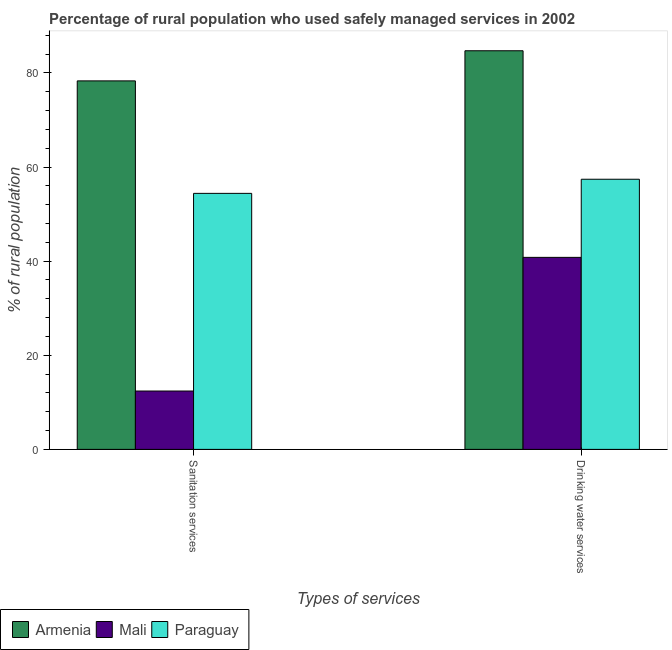How many different coloured bars are there?
Provide a succinct answer. 3. How many groups of bars are there?
Make the answer very short. 2. Are the number of bars on each tick of the X-axis equal?
Offer a terse response. Yes. What is the label of the 1st group of bars from the left?
Provide a short and direct response. Sanitation services. What is the percentage of rural population who used drinking water services in Paraguay?
Offer a very short reply. 57.4. Across all countries, what is the maximum percentage of rural population who used drinking water services?
Offer a terse response. 84.7. In which country was the percentage of rural population who used drinking water services maximum?
Your answer should be compact. Armenia. In which country was the percentage of rural population who used sanitation services minimum?
Provide a short and direct response. Mali. What is the total percentage of rural population who used drinking water services in the graph?
Keep it short and to the point. 182.9. What is the difference between the percentage of rural population who used drinking water services in Paraguay and that in Mali?
Provide a succinct answer. 16.6. What is the difference between the percentage of rural population who used drinking water services in Paraguay and the percentage of rural population who used sanitation services in Armenia?
Make the answer very short. -20.9. What is the average percentage of rural population who used drinking water services per country?
Make the answer very short. 60.97. What is the difference between the percentage of rural population who used sanitation services and percentage of rural population who used drinking water services in Paraguay?
Offer a very short reply. -3. In how many countries, is the percentage of rural population who used sanitation services greater than 28 %?
Your answer should be compact. 2. What is the ratio of the percentage of rural population who used drinking water services in Paraguay to that in Mali?
Keep it short and to the point. 1.41. Is the percentage of rural population who used drinking water services in Armenia less than that in Mali?
Your response must be concise. No. In how many countries, is the percentage of rural population who used drinking water services greater than the average percentage of rural population who used drinking water services taken over all countries?
Your answer should be compact. 1. What does the 1st bar from the left in Drinking water services represents?
Provide a short and direct response. Armenia. What does the 3rd bar from the right in Sanitation services represents?
Your response must be concise. Armenia. How many bars are there?
Make the answer very short. 6. Are all the bars in the graph horizontal?
Offer a terse response. No. Does the graph contain grids?
Your answer should be very brief. No. Where does the legend appear in the graph?
Provide a succinct answer. Bottom left. How are the legend labels stacked?
Make the answer very short. Horizontal. What is the title of the graph?
Give a very brief answer. Percentage of rural population who used safely managed services in 2002. What is the label or title of the X-axis?
Offer a very short reply. Types of services. What is the label or title of the Y-axis?
Offer a very short reply. % of rural population. What is the % of rural population of Armenia in Sanitation services?
Offer a very short reply. 78.3. What is the % of rural population in Paraguay in Sanitation services?
Keep it short and to the point. 54.4. What is the % of rural population in Armenia in Drinking water services?
Provide a short and direct response. 84.7. What is the % of rural population of Mali in Drinking water services?
Provide a short and direct response. 40.8. What is the % of rural population of Paraguay in Drinking water services?
Ensure brevity in your answer.  57.4. Across all Types of services, what is the maximum % of rural population of Armenia?
Give a very brief answer. 84.7. Across all Types of services, what is the maximum % of rural population of Mali?
Your response must be concise. 40.8. Across all Types of services, what is the maximum % of rural population in Paraguay?
Ensure brevity in your answer.  57.4. Across all Types of services, what is the minimum % of rural population of Armenia?
Your answer should be very brief. 78.3. Across all Types of services, what is the minimum % of rural population in Mali?
Your answer should be very brief. 12.4. Across all Types of services, what is the minimum % of rural population of Paraguay?
Give a very brief answer. 54.4. What is the total % of rural population in Armenia in the graph?
Your answer should be compact. 163. What is the total % of rural population of Mali in the graph?
Your answer should be very brief. 53.2. What is the total % of rural population of Paraguay in the graph?
Make the answer very short. 111.8. What is the difference between the % of rural population of Armenia in Sanitation services and that in Drinking water services?
Your answer should be very brief. -6.4. What is the difference between the % of rural population in Mali in Sanitation services and that in Drinking water services?
Ensure brevity in your answer.  -28.4. What is the difference between the % of rural population of Armenia in Sanitation services and the % of rural population of Mali in Drinking water services?
Keep it short and to the point. 37.5. What is the difference between the % of rural population in Armenia in Sanitation services and the % of rural population in Paraguay in Drinking water services?
Provide a succinct answer. 20.9. What is the difference between the % of rural population in Mali in Sanitation services and the % of rural population in Paraguay in Drinking water services?
Keep it short and to the point. -45. What is the average % of rural population of Armenia per Types of services?
Provide a short and direct response. 81.5. What is the average % of rural population in Mali per Types of services?
Your response must be concise. 26.6. What is the average % of rural population of Paraguay per Types of services?
Your response must be concise. 55.9. What is the difference between the % of rural population of Armenia and % of rural population of Mali in Sanitation services?
Make the answer very short. 65.9. What is the difference between the % of rural population of Armenia and % of rural population of Paraguay in Sanitation services?
Ensure brevity in your answer.  23.9. What is the difference between the % of rural population in Mali and % of rural population in Paraguay in Sanitation services?
Keep it short and to the point. -42. What is the difference between the % of rural population in Armenia and % of rural population in Mali in Drinking water services?
Give a very brief answer. 43.9. What is the difference between the % of rural population in Armenia and % of rural population in Paraguay in Drinking water services?
Ensure brevity in your answer.  27.3. What is the difference between the % of rural population of Mali and % of rural population of Paraguay in Drinking water services?
Ensure brevity in your answer.  -16.6. What is the ratio of the % of rural population in Armenia in Sanitation services to that in Drinking water services?
Provide a succinct answer. 0.92. What is the ratio of the % of rural population in Mali in Sanitation services to that in Drinking water services?
Your answer should be compact. 0.3. What is the ratio of the % of rural population in Paraguay in Sanitation services to that in Drinking water services?
Provide a succinct answer. 0.95. What is the difference between the highest and the second highest % of rural population of Mali?
Give a very brief answer. 28.4. What is the difference between the highest and the lowest % of rural population in Mali?
Offer a very short reply. 28.4. 